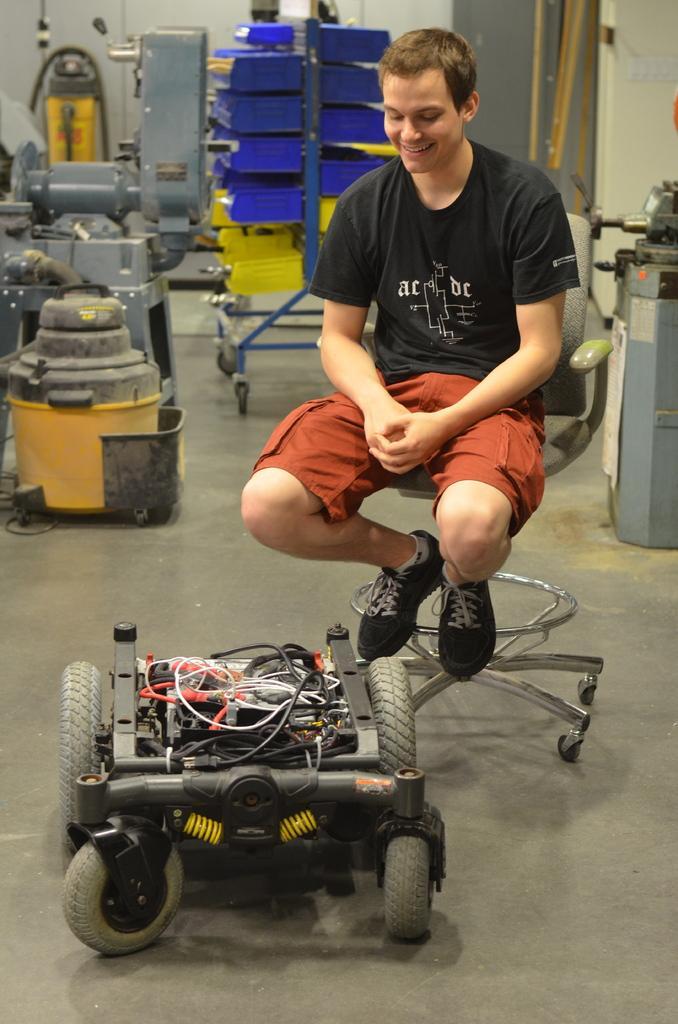Please provide a concise description of this image. Here there is a small vehicle on the floor and a man sitting on the chair. In the background there are machines,trolley,some other objects and a wall. 